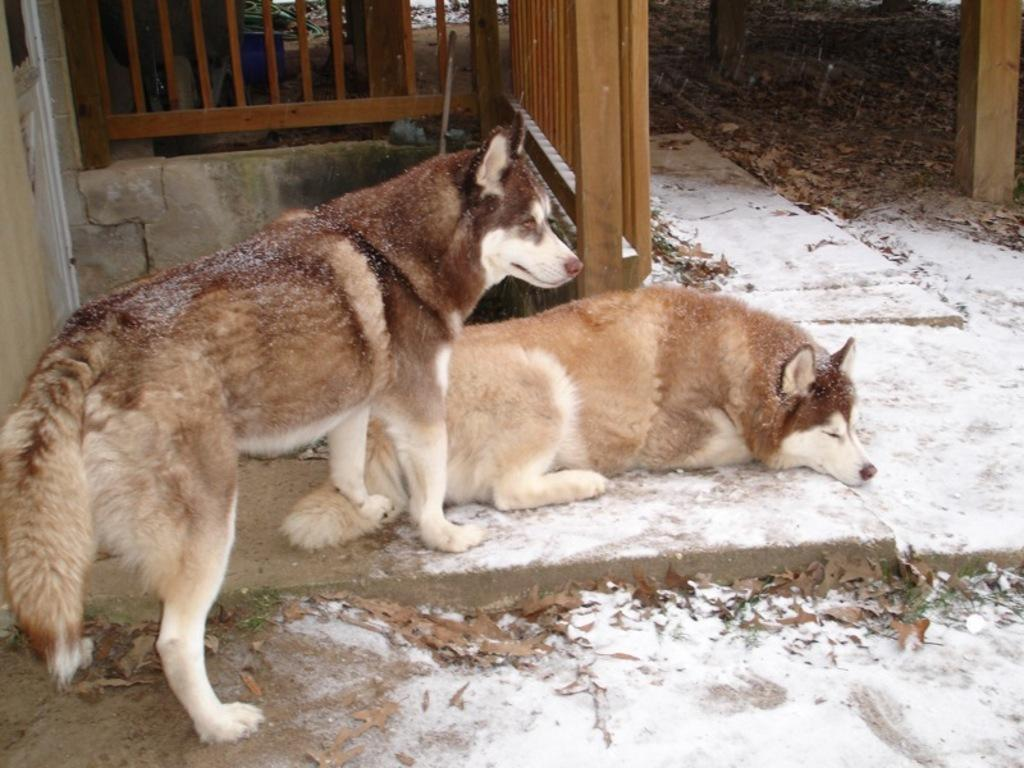How many huskies are in the image? There are two huskies in the image. What are the positions of the huskies in the image? One husky is standing, and the other is lying on the floor. What is covering the floor in the image? The floor is covered with snow and leaves. What can be seen in the background of the image? There is a wooden fence in the background of the image. What type of stamp can be seen on the husky's paw in the image? There is no stamp visible on the huskies' paws in the image. What is the friction between the standing husky and the wooden fence in the image? There is no information about friction between the husky and the wooden fence in the image. 